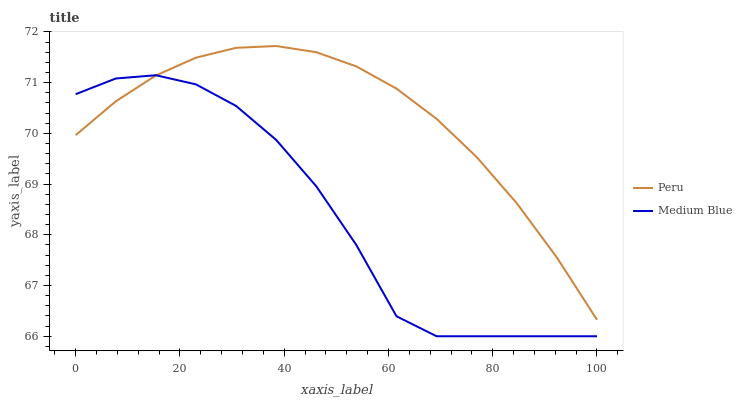Does Peru have the minimum area under the curve?
Answer yes or no. No. Is Peru the roughest?
Answer yes or no. No. Does Peru have the lowest value?
Answer yes or no. No. 